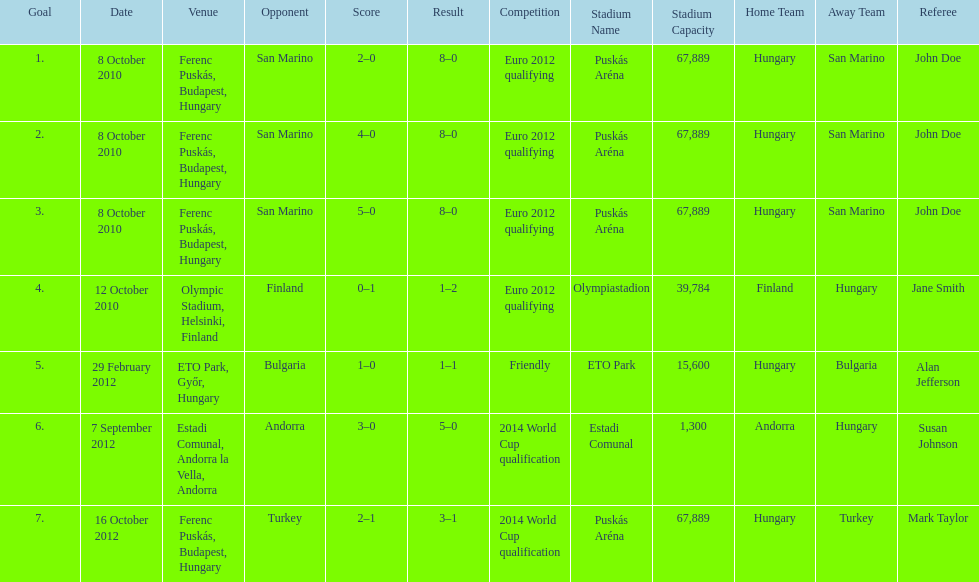Szalai scored only one more international goal against all other countries put together than he did against what one country? San Marino. 